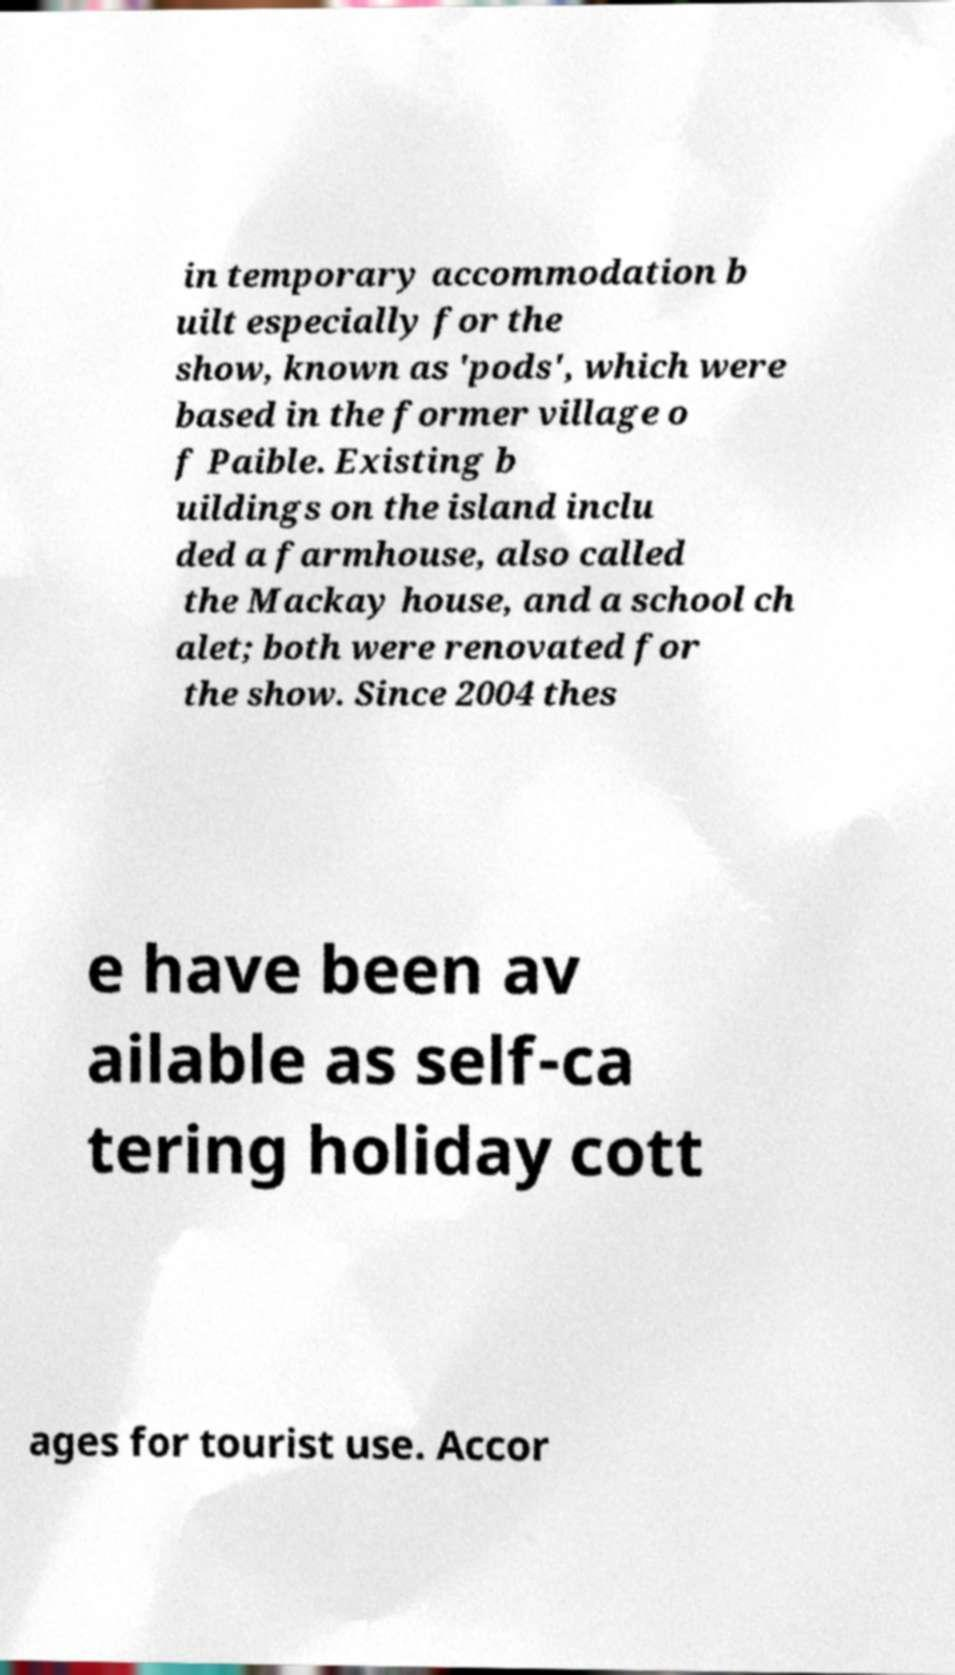Could you extract and type out the text from this image? in temporary accommodation b uilt especially for the show, known as 'pods', which were based in the former village o f Paible. Existing b uildings on the island inclu ded a farmhouse, also called the Mackay house, and a school ch alet; both were renovated for the show. Since 2004 thes e have been av ailable as self-ca tering holiday cott ages for tourist use. Accor 